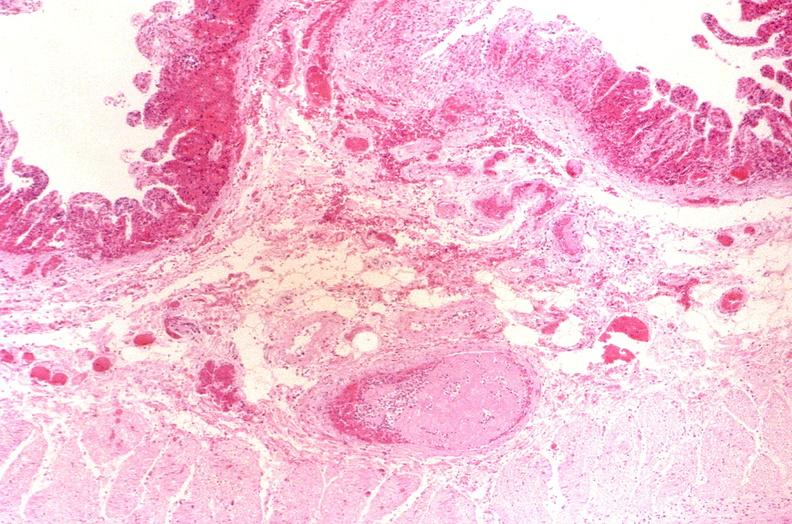s gastrointestinal present?
Answer the question using a single word or phrase. Yes 